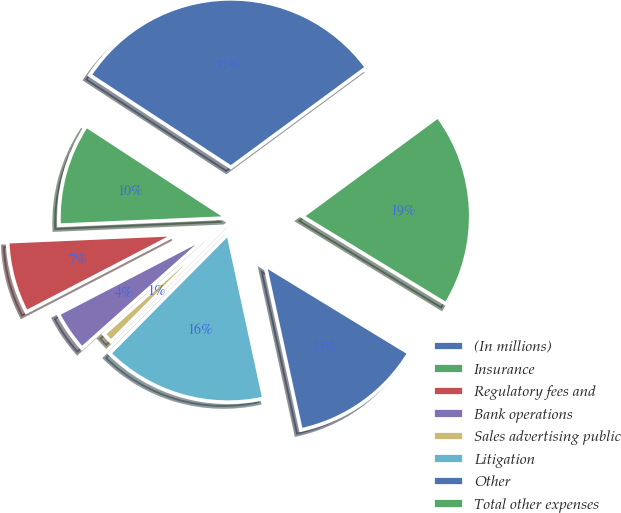<chart> <loc_0><loc_0><loc_500><loc_500><pie_chart><fcel>(In millions)<fcel>Insurance<fcel>Regulatory fees and<fcel>Bank operations<fcel>Sales advertising public<fcel>Litigation<fcel>Other<fcel>Total other expenses<nl><fcel>30.69%<fcel>9.9%<fcel>6.93%<fcel>3.96%<fcel>0.99%<fcel>15.84%<fcel>12.87%<fcel>18.81%<nl></chart> 